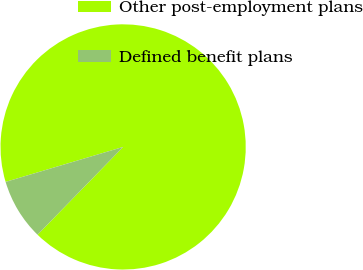Convert chart to OTSL. <chart><loc_0><loc_0><loc_500><loc_500><pie_chart><fcel>Other post-employment plans<fcel>Defined benefit plans<nl><fcel>91.9%<fcel>8.1%<nl></chart> 